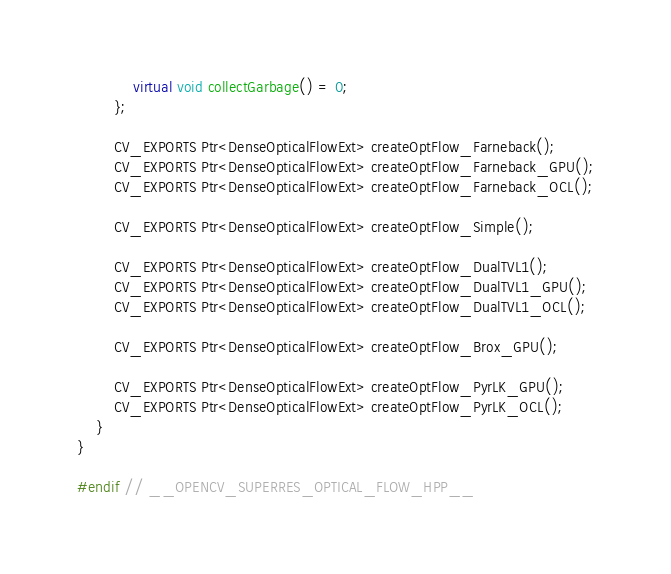Convert code to text. <code><loc_0><loc_0><loc_500><loc_500><_C++_>            virtual void collectGarbage() = 0;
        };

        CV_EXPORTS Ptr<DenseOpticalFlowExt> createOptFlow_Farneback();
        CV_EXPORTS Ptr<DenseOpticalFlowExt> createOptFlow_Farneback_GPU();
        CV_EXPORTS Ptr<DenseOpticalFlowExt> createOptFlow_Farneback_OCL();

        CV_EXPORTS Ptr<DenseOpticalFlowExt> createOptFlow_Simple();

        CV_EXPORTS Ptr<DenseOpticalFlowExt> createOptFlow_DualTVL1();
        CV_EXPORTS Ptr<DenseOpticalFlowExt> createOptFlow_DualTVL1_GPU();
        CV_EXPORTS Ptr<DenseOpticalFlowExt> createOptFlow_DualTVL1_OCL();

        CV_EXPORTS Ptr<DenseOpticalFlowExt> createOptFlow_Brox_GPU();

        CV_EXPORTS Ptr<DenseOpticalFlowExt> createOptFlow_PyrLK_GPU();
        CV_EXPORTS Ptr<DenseOpticalFlowExt> createOptFlow_PyrLK_OCL();
    }
}

#endif // __OPENCV_SUPERRES_OPTICAL_FLOW_HPP__
</code> 